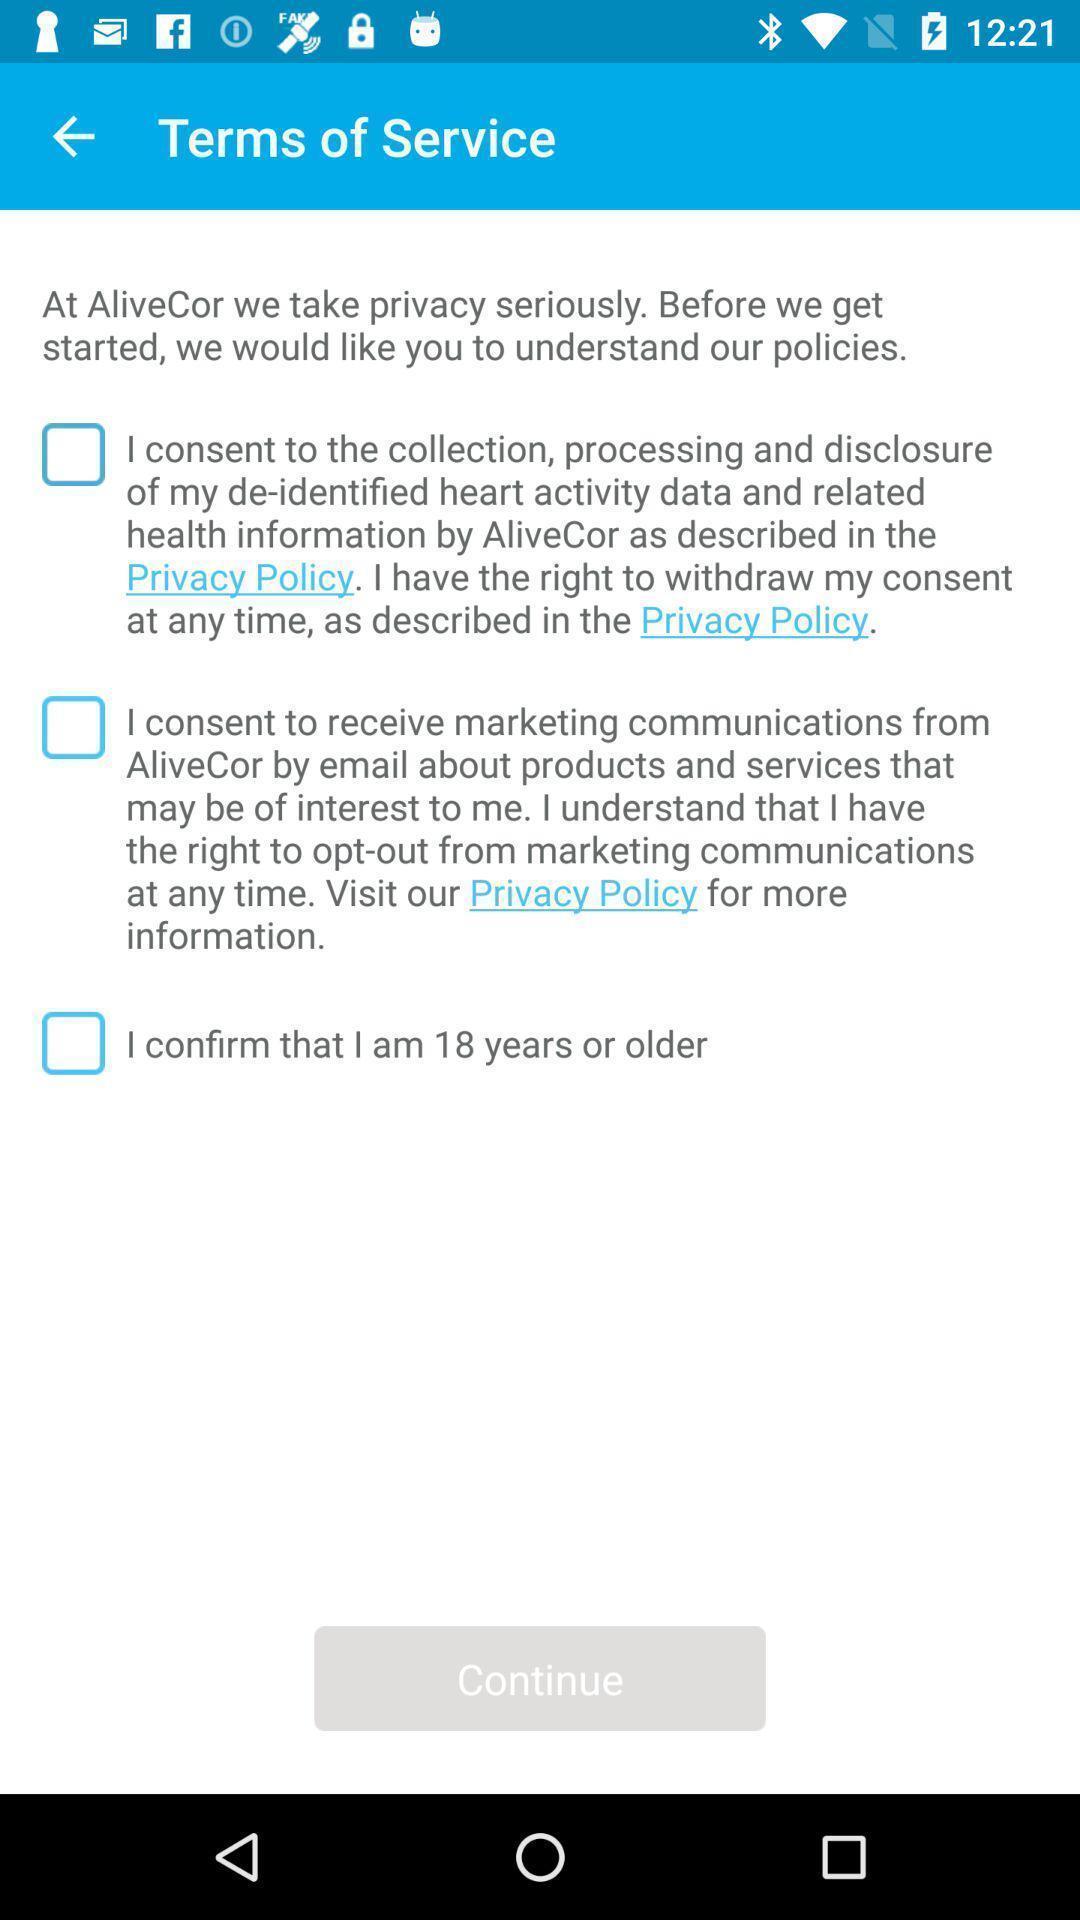Summarize the information in this screenshot. Page is showing terms of service. 